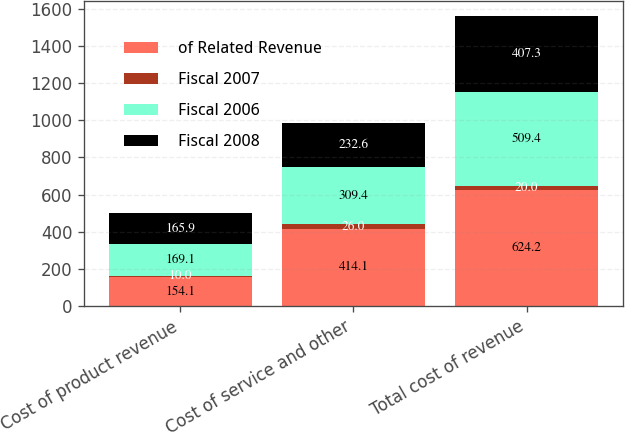<chart> <loc_0><loc_0><loc_500><loc_500><stacked_bar_chart><ecel><fcel>Cost of product revenue<fcel>Cost of service and other<fcel>Total cost of revenue<nl><fcel>of Related Revenue<fcel>154.1<fcel>414.1<fcel>624.2<nl><fcel>Fiscal 2007<fcel>10<fcel>26<fcel>20<nl><fcel>Fiscal 2006<fcel>169.1<fcel>309.4<fcel>509.4<nl><fcel>Fiscal 2008<fcel>165.9<fcel>232.6<fcel>407.3<nl></chart> 